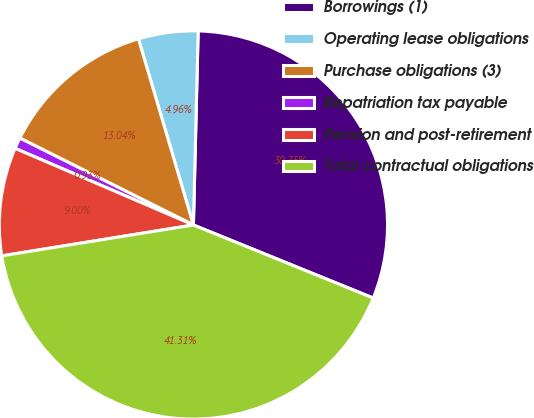Convert chart to OTSL. <chart><loc_0><loc_0><loc_500><loc_500><pie_chart><fcel>Borrowings (1)<fcel>Operating lease obligations<fcel>Purchase obligations (3)<fcel>Repatriation tax payable<fcel>Pension and post-retirement<fcel>Total contractual obligations<nl><fcel>30.75%<fcel>4.96%<fcel>13.04%<fcel>0.93%<fcel>9.0%<fcel>41.31%<nl></chart> 